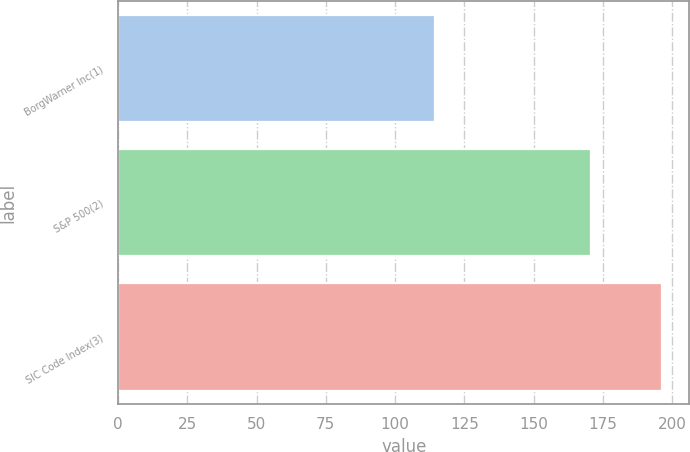Convert chart to OTSL. <chart><loc_0><loc_0><loc_500><loc_500><bar_chart><fcel>BorgWarner Inc(1)<fcel>S&P 500(2)<fcel>SIC Code Index(3)<nl><fcel>114.58<fcel>170.84<fcel>196.44<nl></chart> 